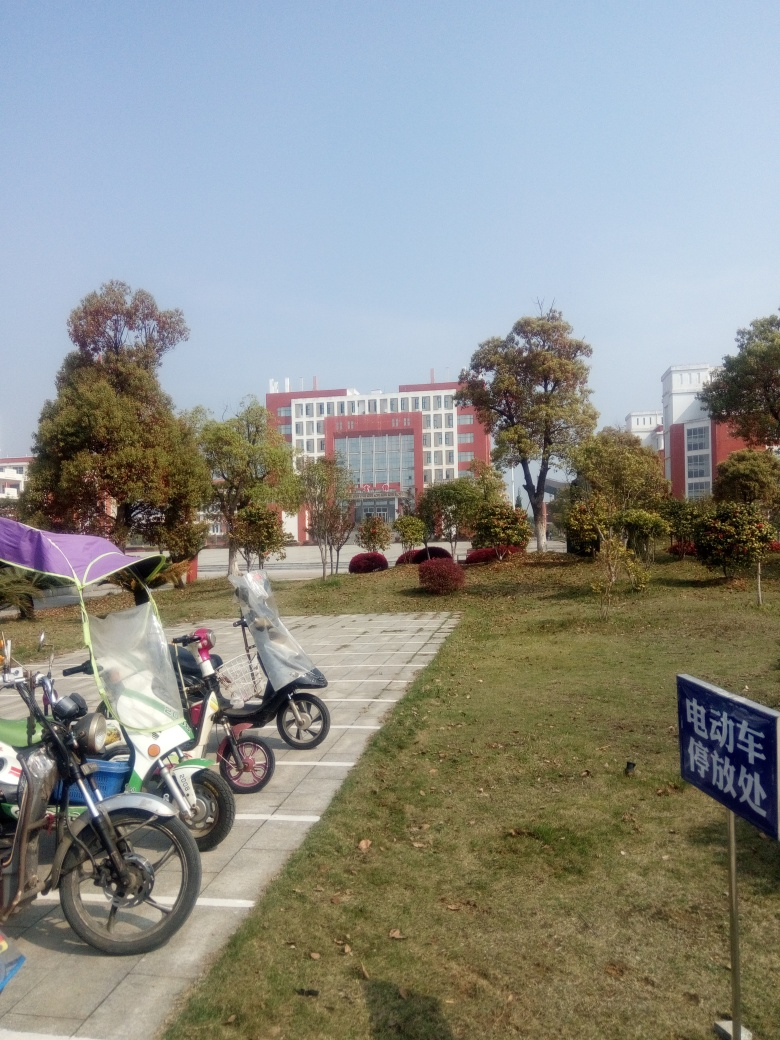Can you describe the type of location depicted in this image? The image shows an urban setting, likely a public space with a paved path leading towards a contemporary-looking red and white building, which might be an institutional or commercial structure. There are parked bicycles and a scooter on the side, suggesting this is an area where locals transit or converge. What can we infer about the weather and season from this image? Given the clear skies and the lack of leaves on one of the trees, it might suggest a day with good weather, likely in a transition season such as late fall or early spring, where temperatures are moderate. 